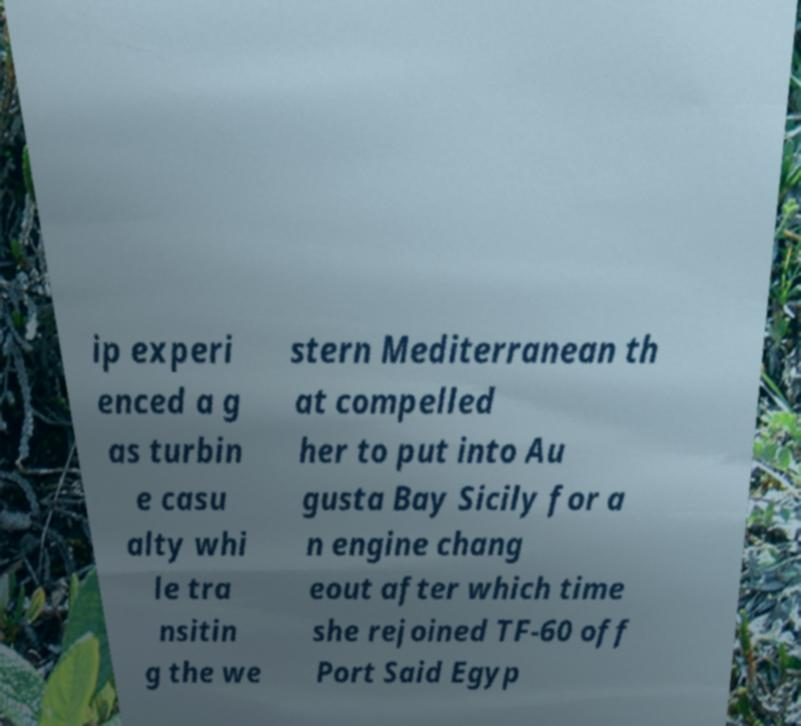For documentation purposes, I need the text within this image transcribed. Could you provide that? ip experi enced a g as turbin e casu alty whi le tra nsitin g the we stern Mediterranean th at compelled her to put into Au gusta Bay Sicily for a n engine chang eout after which time she rejoined TF-60 off Port Said Egyp 